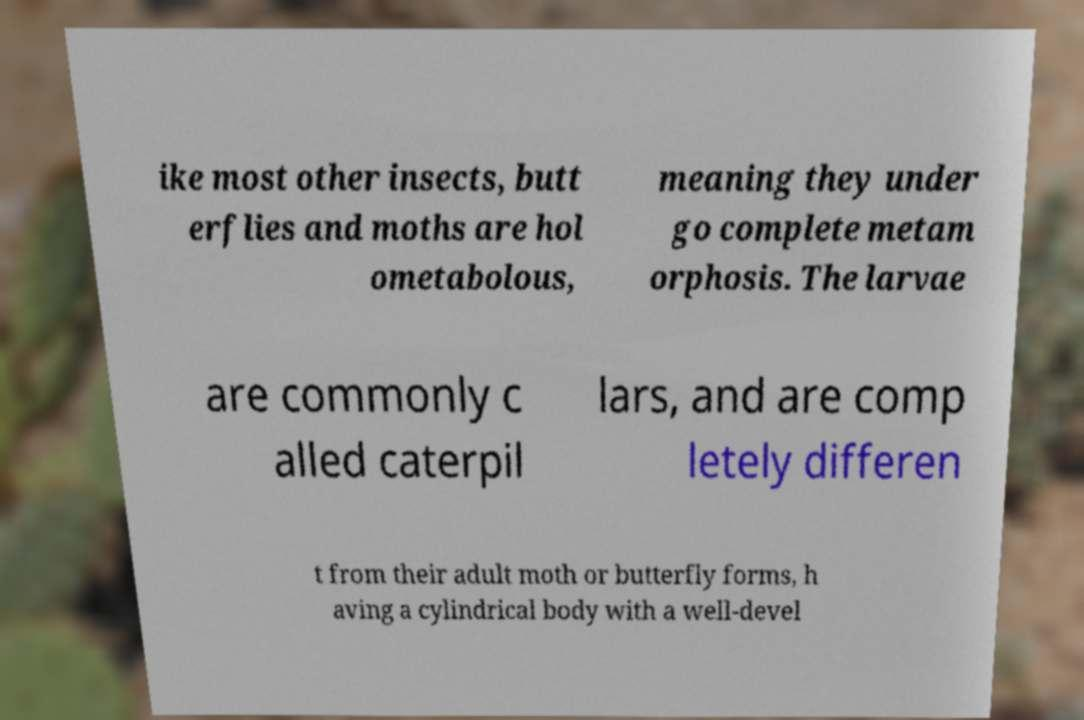For documentation purposes, I need the text within this image transcribed. Could you provide that? ike most other insects, butt erflies and moths are hol ometabolous, meaning they under go complete metam orphosis. The larvae are commonly c alled caterpil lars, and are comp letely differen t from their adult moth or butterfly forms, h aving a cylindrical body with a well-devel 